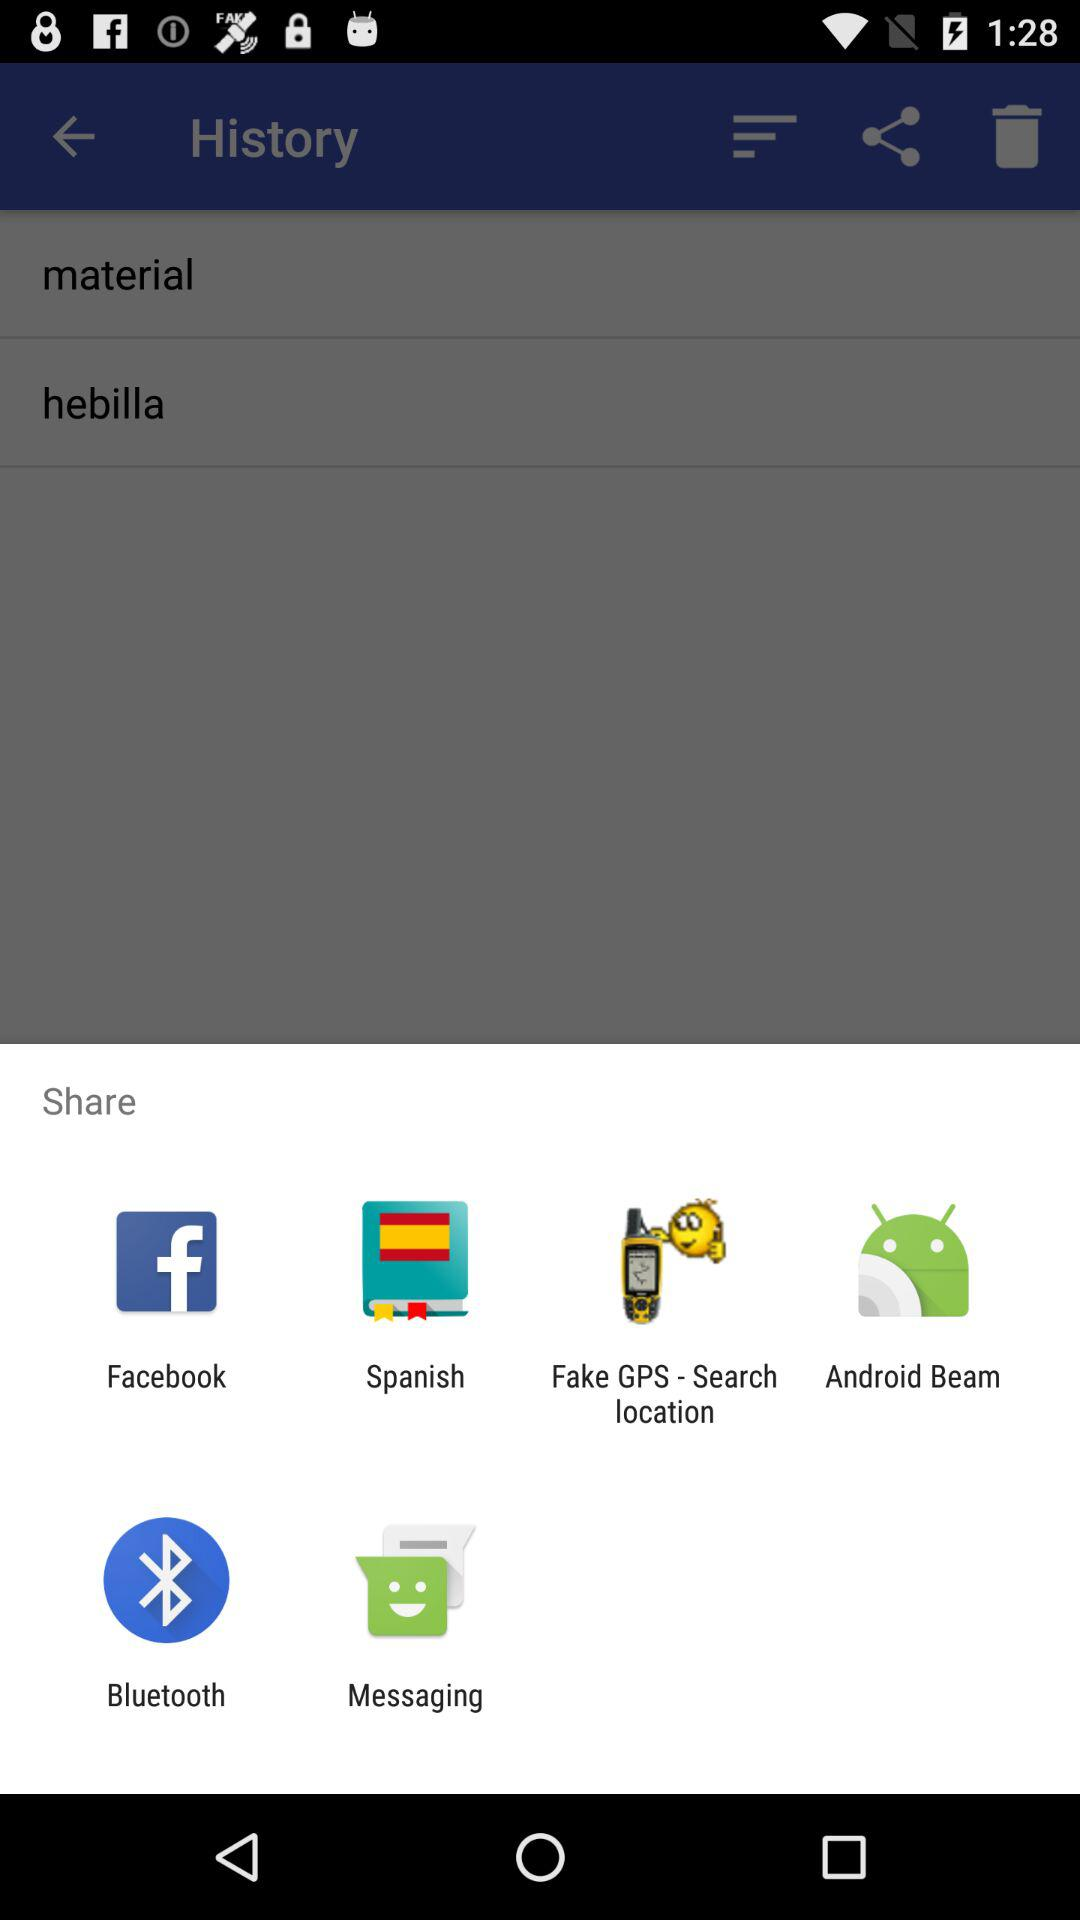Which are the different sharing options? The different sharing options are "Facebook", "Spanish", "Fake GPS - Search location", "Android Beam", "Bluetooth" and "Messaging". 